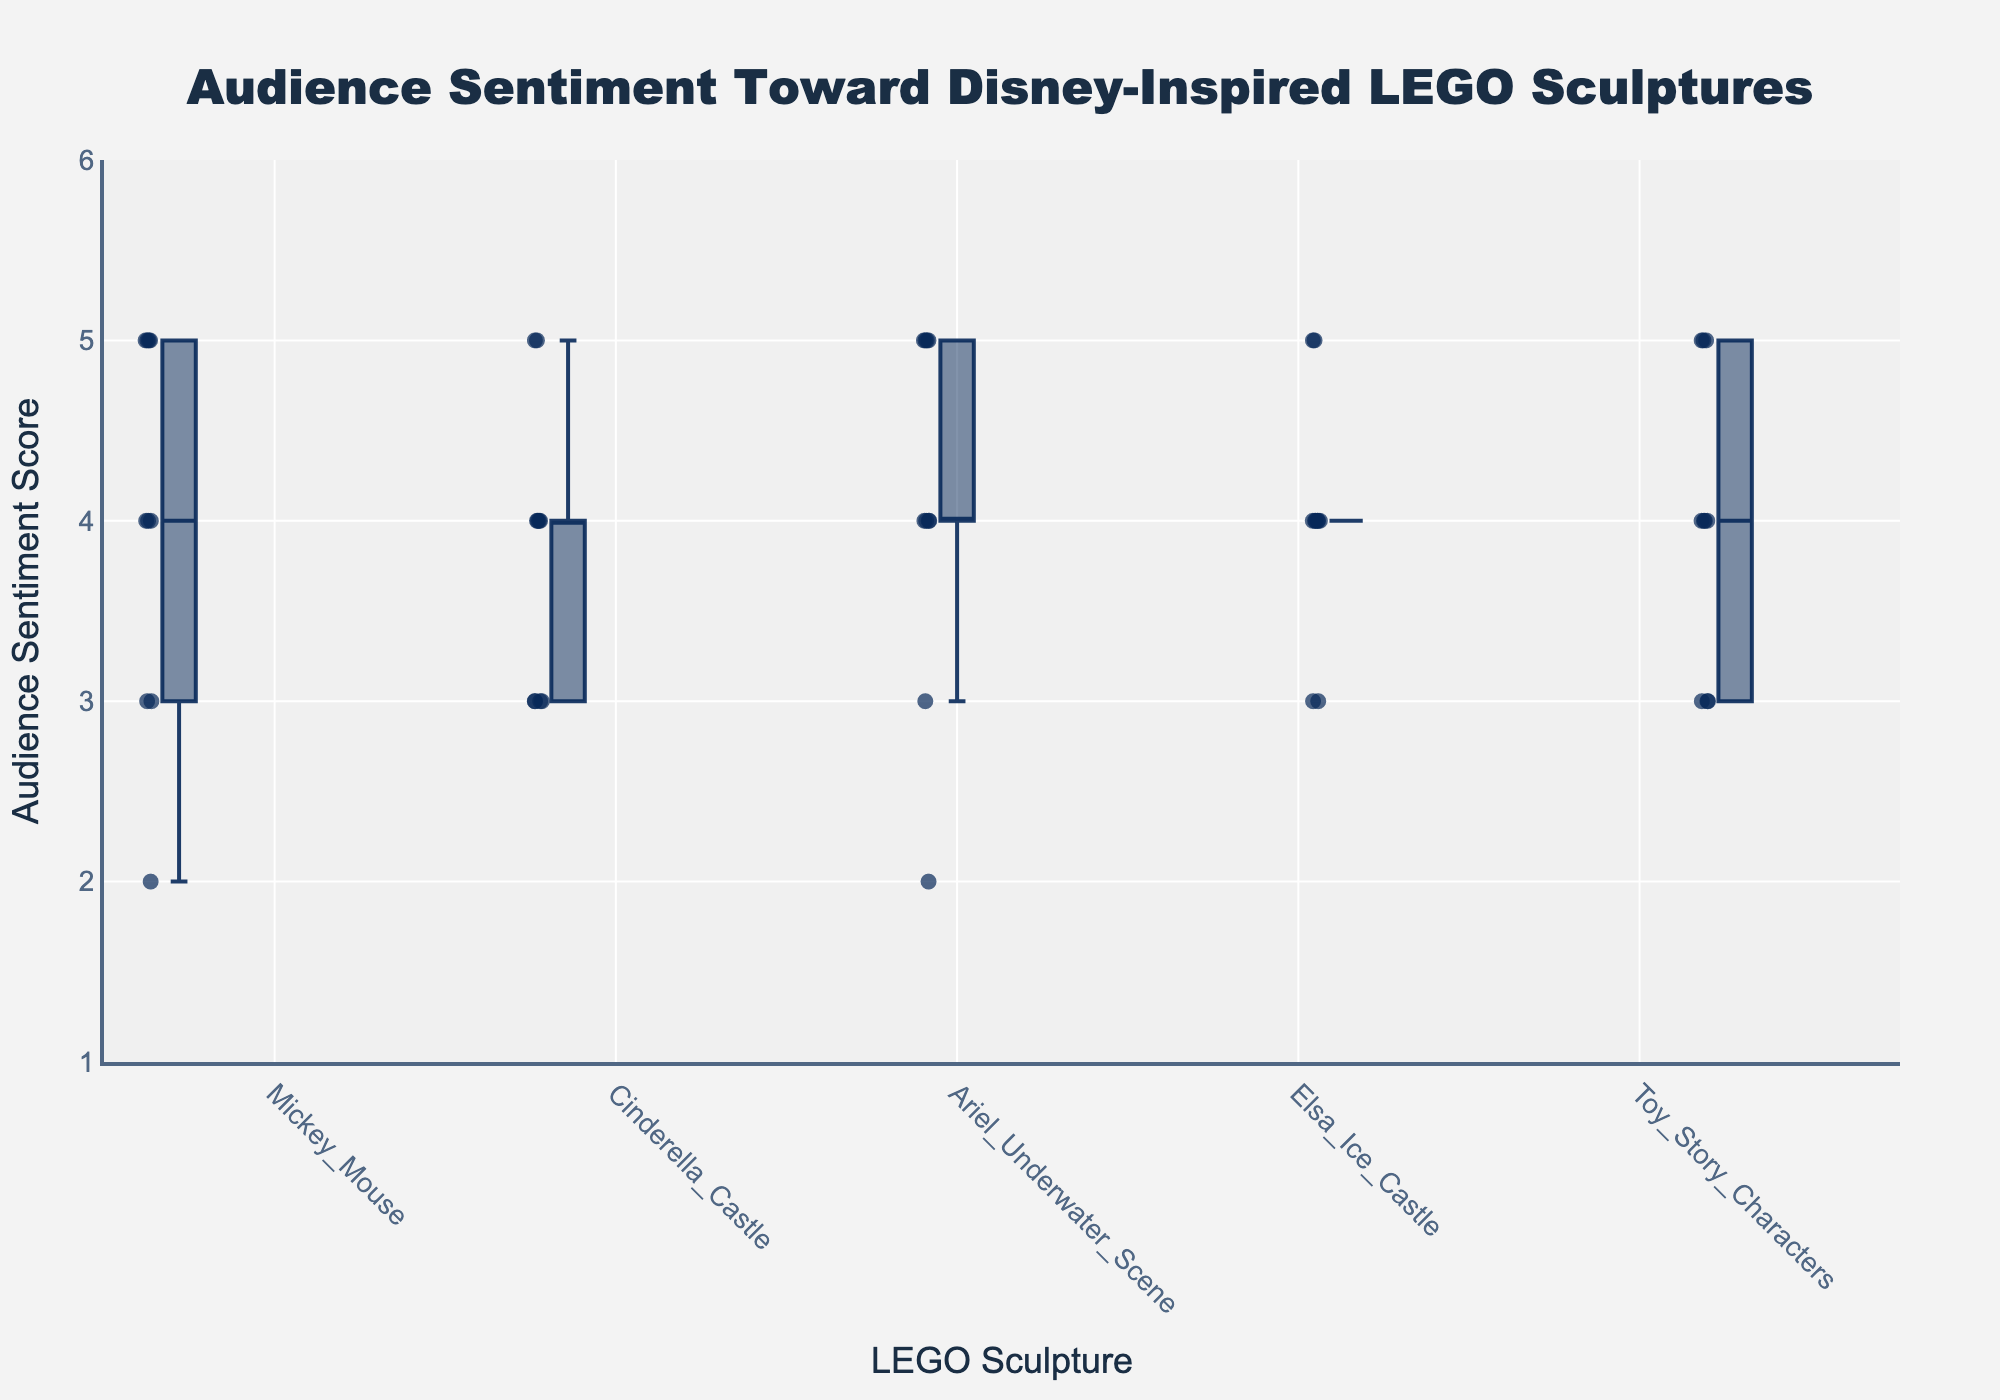What is the title of the figure? The title of the figure is written at the top of the plot, often in a larger and bold font. It provides a summary or the main topic of the data visualization.
Answer: Audience Sentiment Toward Disney-Inspired LEGO Sculptures What is the median audience sentiment for the Mickey Mouse sculpture? The median is found by sorting the values and selecting the middle one. For Mickey Mouse: 2, 3, 3, 4, 4, 4, 5, 5, 5, 5. The median is the average of the two middle numbers (4 and 4).
Answer: 4 Which sculpture has the highest maximum audience sentiment? The maximum value shown by the top whisker or outlier for each sculpture indicates the highest audience sentiment. By comparing the highest value of each sculpture, Ariel Underwater Scene, Mickey Mouse, and Cinderella Castle share the highest value.
Answer: Ariel Underwater Scene, Mickey Mouse, Cinderella Castle Which sculpture shows the lowest audience sentiment value? The lowest value shown by the bottom whisker or outlier for each sculpture indicates the lowest audience sentiment. By comparing the lowest value of each sculpture, it's seen that Mickey Mouse and Ariel Underwater Scene have the lowest value.
Answer: Mickey Mouse, Ariel Underwater Scene What is the interquartile range (IQR) of audience sentiment for the Ariel Underwater Scene? The IQR is the difference between the third quartile (75th percentile) and the first quartile (25th percentile). For Ariel Underwater Scene, the first quartile is 4 and the third quartile is 5, so IQR = 5 - 4.
Answer: 1 In which sculpture is the audience sentiment most consistent? Consistency can be measured by the range of quartiles. The smallest range indicates the most consistent sentiment. Elsa Ice Castle has a very tight box, indicating consistent audience sentiment.
Answer: Elsa Ice Castle How many outliers are there for the Cinderella Castle sculpture based on the plot? Outliers are typically represented by points outside the whiskers of the box plot. For Cinderella Castle, there are no data points outside the whiskers visible in the plot.
Answer: 0 Which sculpture has the widest range of audience sentiment? The range is the difference between the maximum and minimum values. Comparing the whiskers of all plots, Mickey Mouse stretches from 2 to 5, giving it the widest range.
Answer: Mickey Mouse Is the audience sentiment score for Toy Story Characters generally higher or lower than that for Cinderella Castle? By comparing the median lines of both box plots, you can see that the median of Toy Story Characters is higher (4) than that of Cinderella Castle (3.5).
Answer: Higher Which sculpture has a median audience sentiment equal to 4? The median is the line within the box plot. By examining all, Mickey Mouse, Ariel Underwater Scene, Elsa Ice Castle, and Toy Story Characters have medians equal to 4.
Answer: Mickey Mouse, Ariel Underwater Scene, Elsa Ice Castle, Toy Story Characters 